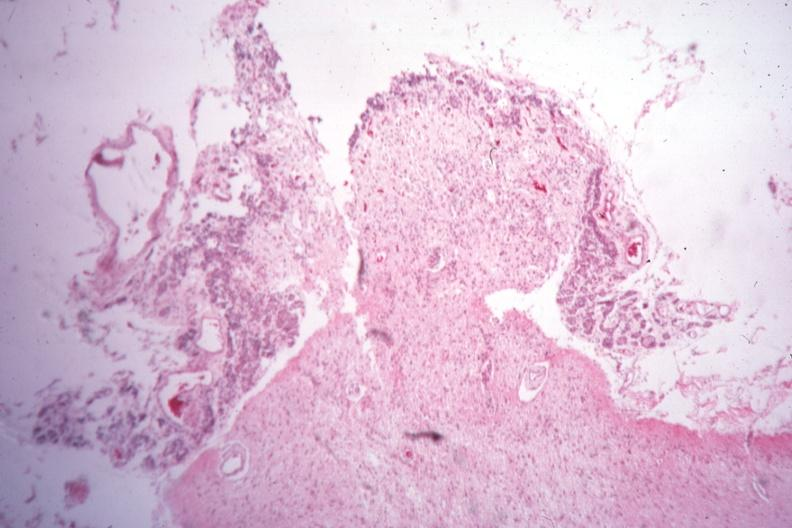was pus in test tube empty case of type i diabetes with pituitectomy for retinal lesions 9 years?
Answer the question using a single word or phrase. No 